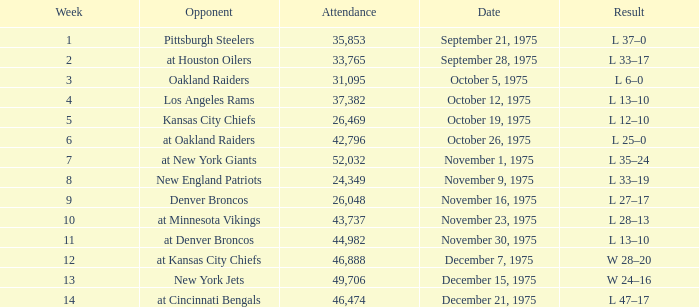What is the highest Week when the opponent was the los angeles rams, with more than 37,382 in Attendance? None. 